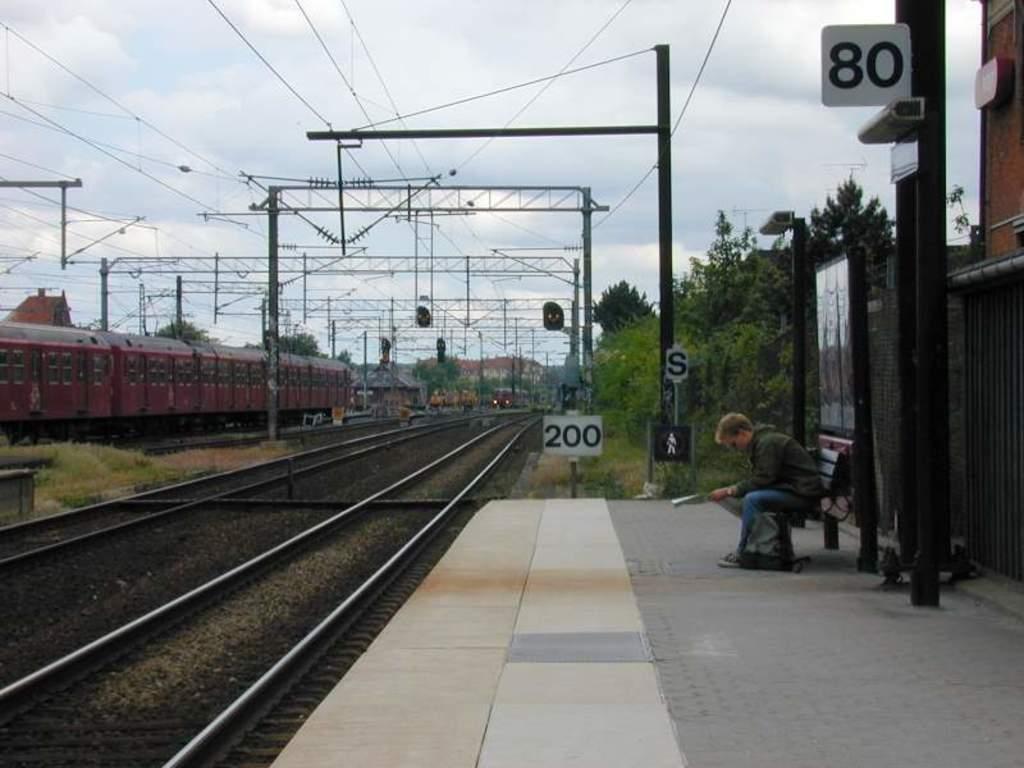How would you summarize this image in a sentence or two? There is one man sitting on a table is on the right side of this image. We can see trees and poles are present behind this person. There are railway tracks and a train is present on the left side of this image. We can see poles in the middle of this image and the sky is in the background. There is a platform at the bottom of this image. 